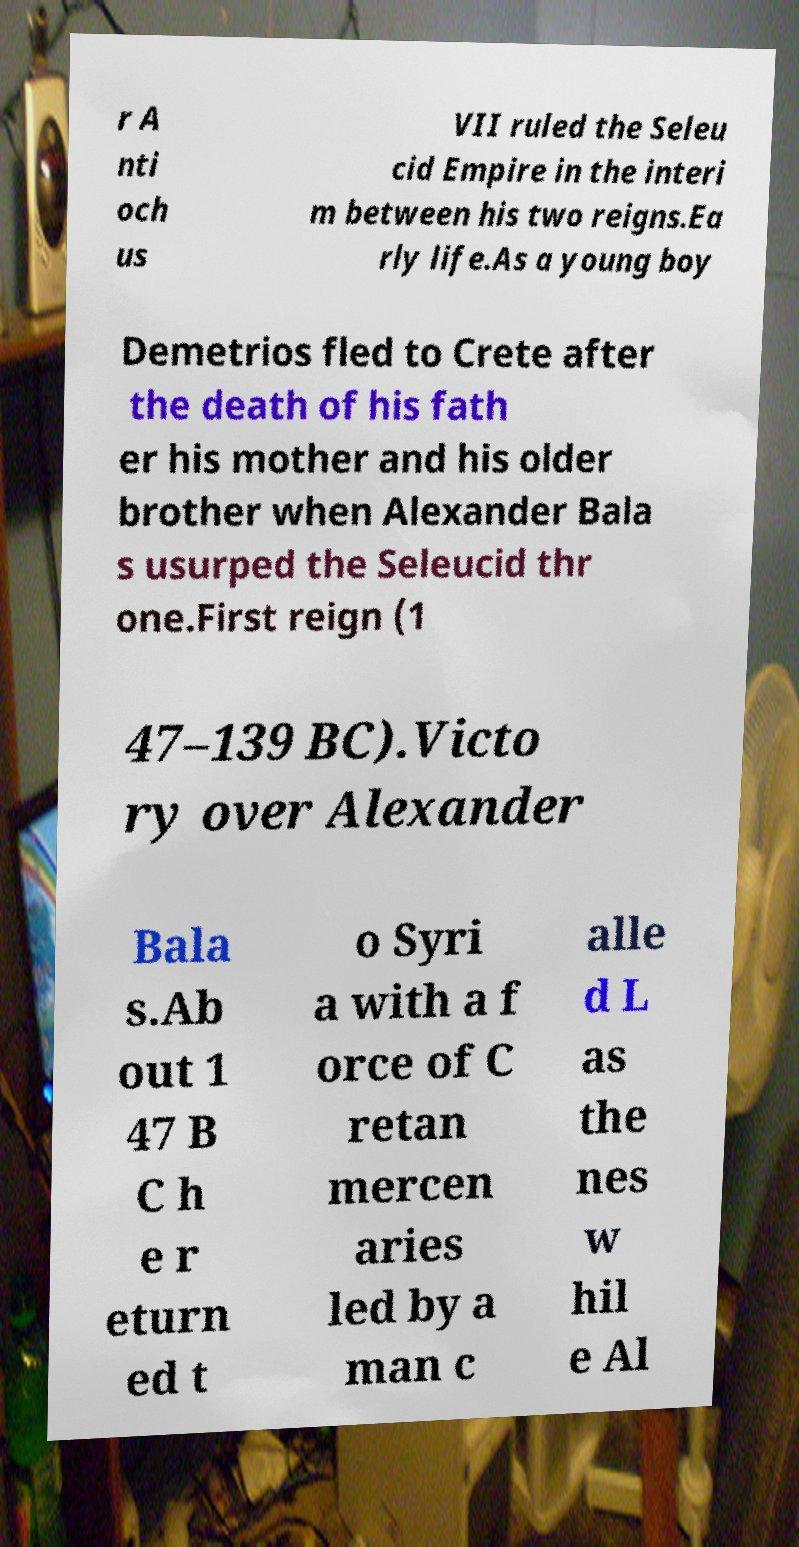Can you read and provide the text displayed in the image?This photo seems to have some interesting text. Can you extract and type it out for me? r A nti och us VII ruled the Seleu cid Empire in the interi m between his two reigns.Ea rly life.As a young boy Demetrios fled to Crete after the death of his fath er his mother and his older brother when Alexander Bala s usurped the Seleucid thr one.First reign (1 47–139 BC).Victo ry over Alexander Bala s.Ab out 1 47 B C h e r eturn ed t o Syri a with a f orce of C retan mercen aries led by a man c alle d L as the nes w hil e Al 